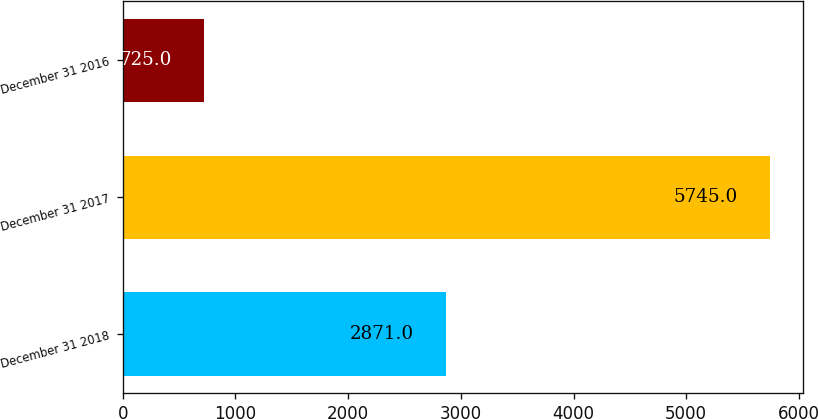Convert chart. <chart><loc_0><loc_0><loc_500><loc_500><bar_chart><fcel>December 31 2018<fcel>December 31 2017<fcel>December 31 2016<nl><fcel>2871<fcel>5745<fcel>725<nl></chart> 